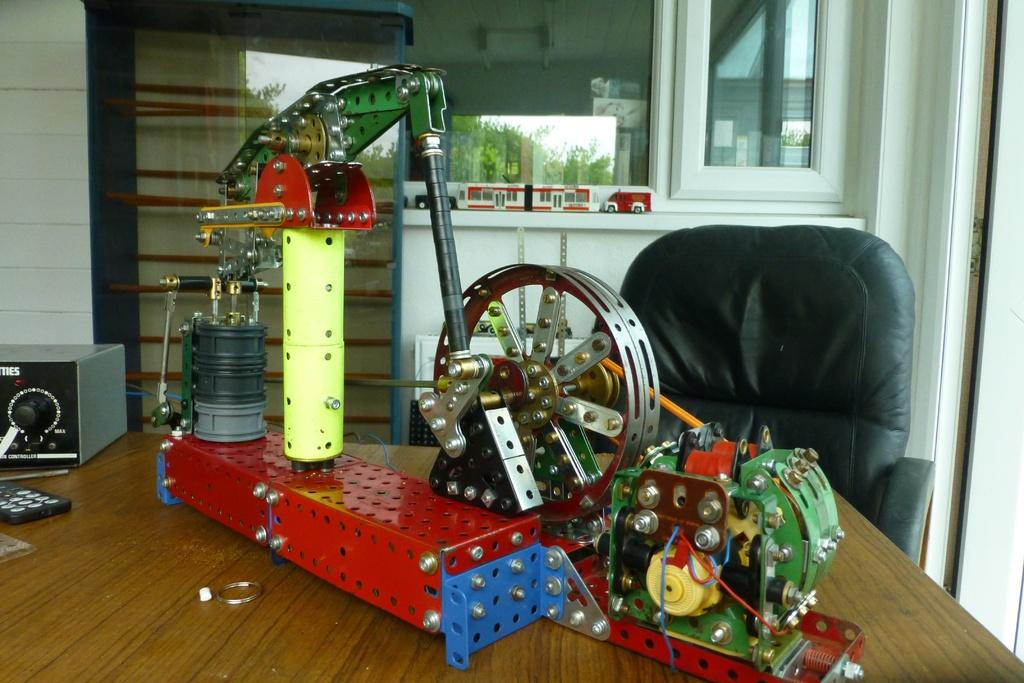What type of structure can be seen in the image? There is a wall in the image. What feature is present in the wall? There is a window in the image. What type of furniture is visible in the image? There is a chair and a table in the image. What is placed on the table? There is electrical equipment on the table. What can be seen in the reflection of the image? There is a reflection of trees in the image. What type of bait is used to catch fish in the image? There is no mention of fish or bait in the image; it features a wall, window, chair, table, electrical equipment, and a reflection of trees. What type of cord is connected to the electrical equipment in the image? The image does not provide information about any cords connected to the electrical equipment. 